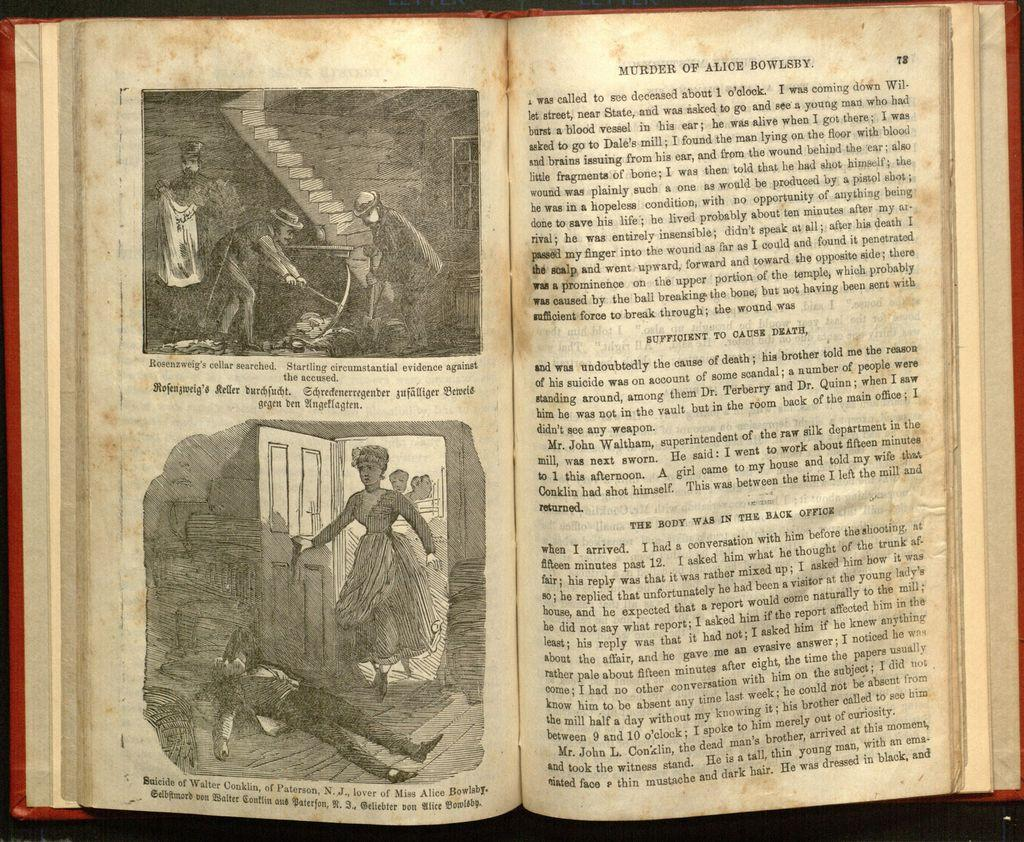Provide a one-sentence caption for the provided image. A open old book with a pages titled Murder by Alice Bowleby. 